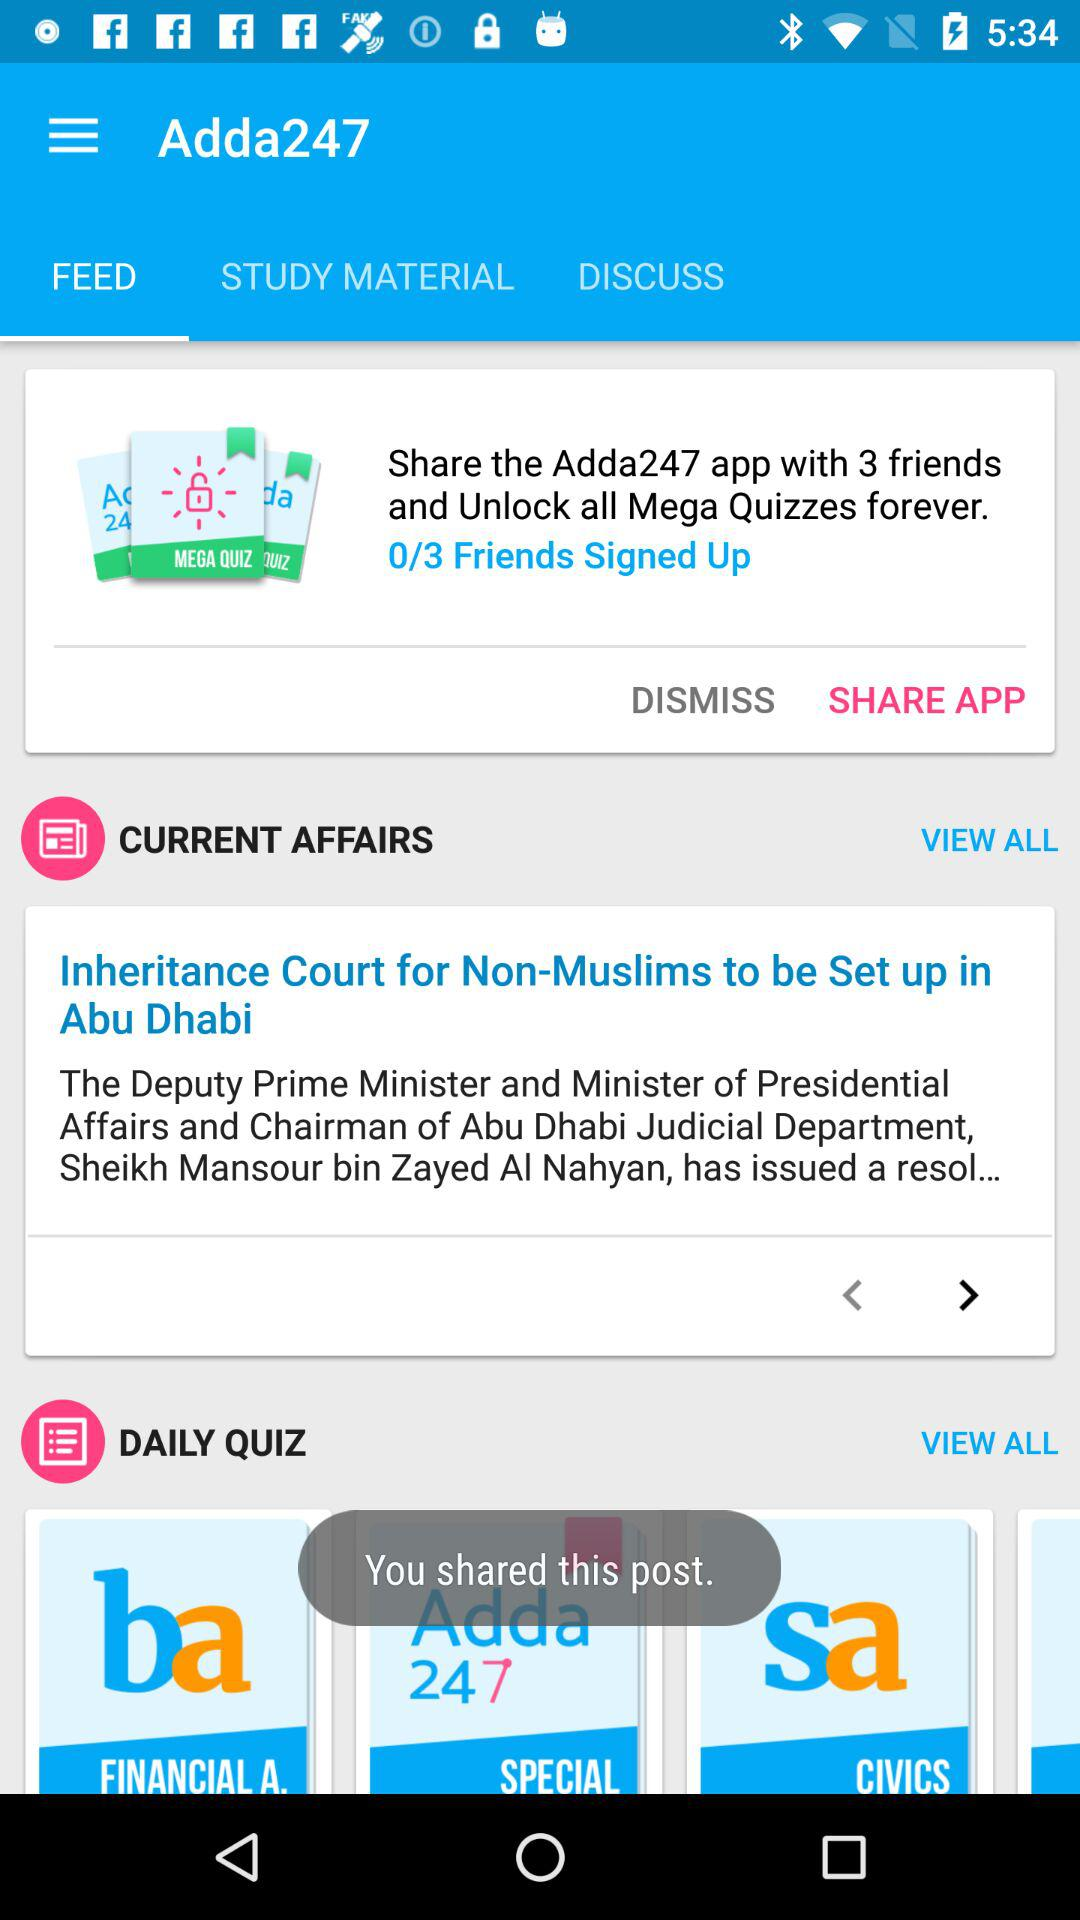What is the name of the application? The name of the application is "Adda247". 